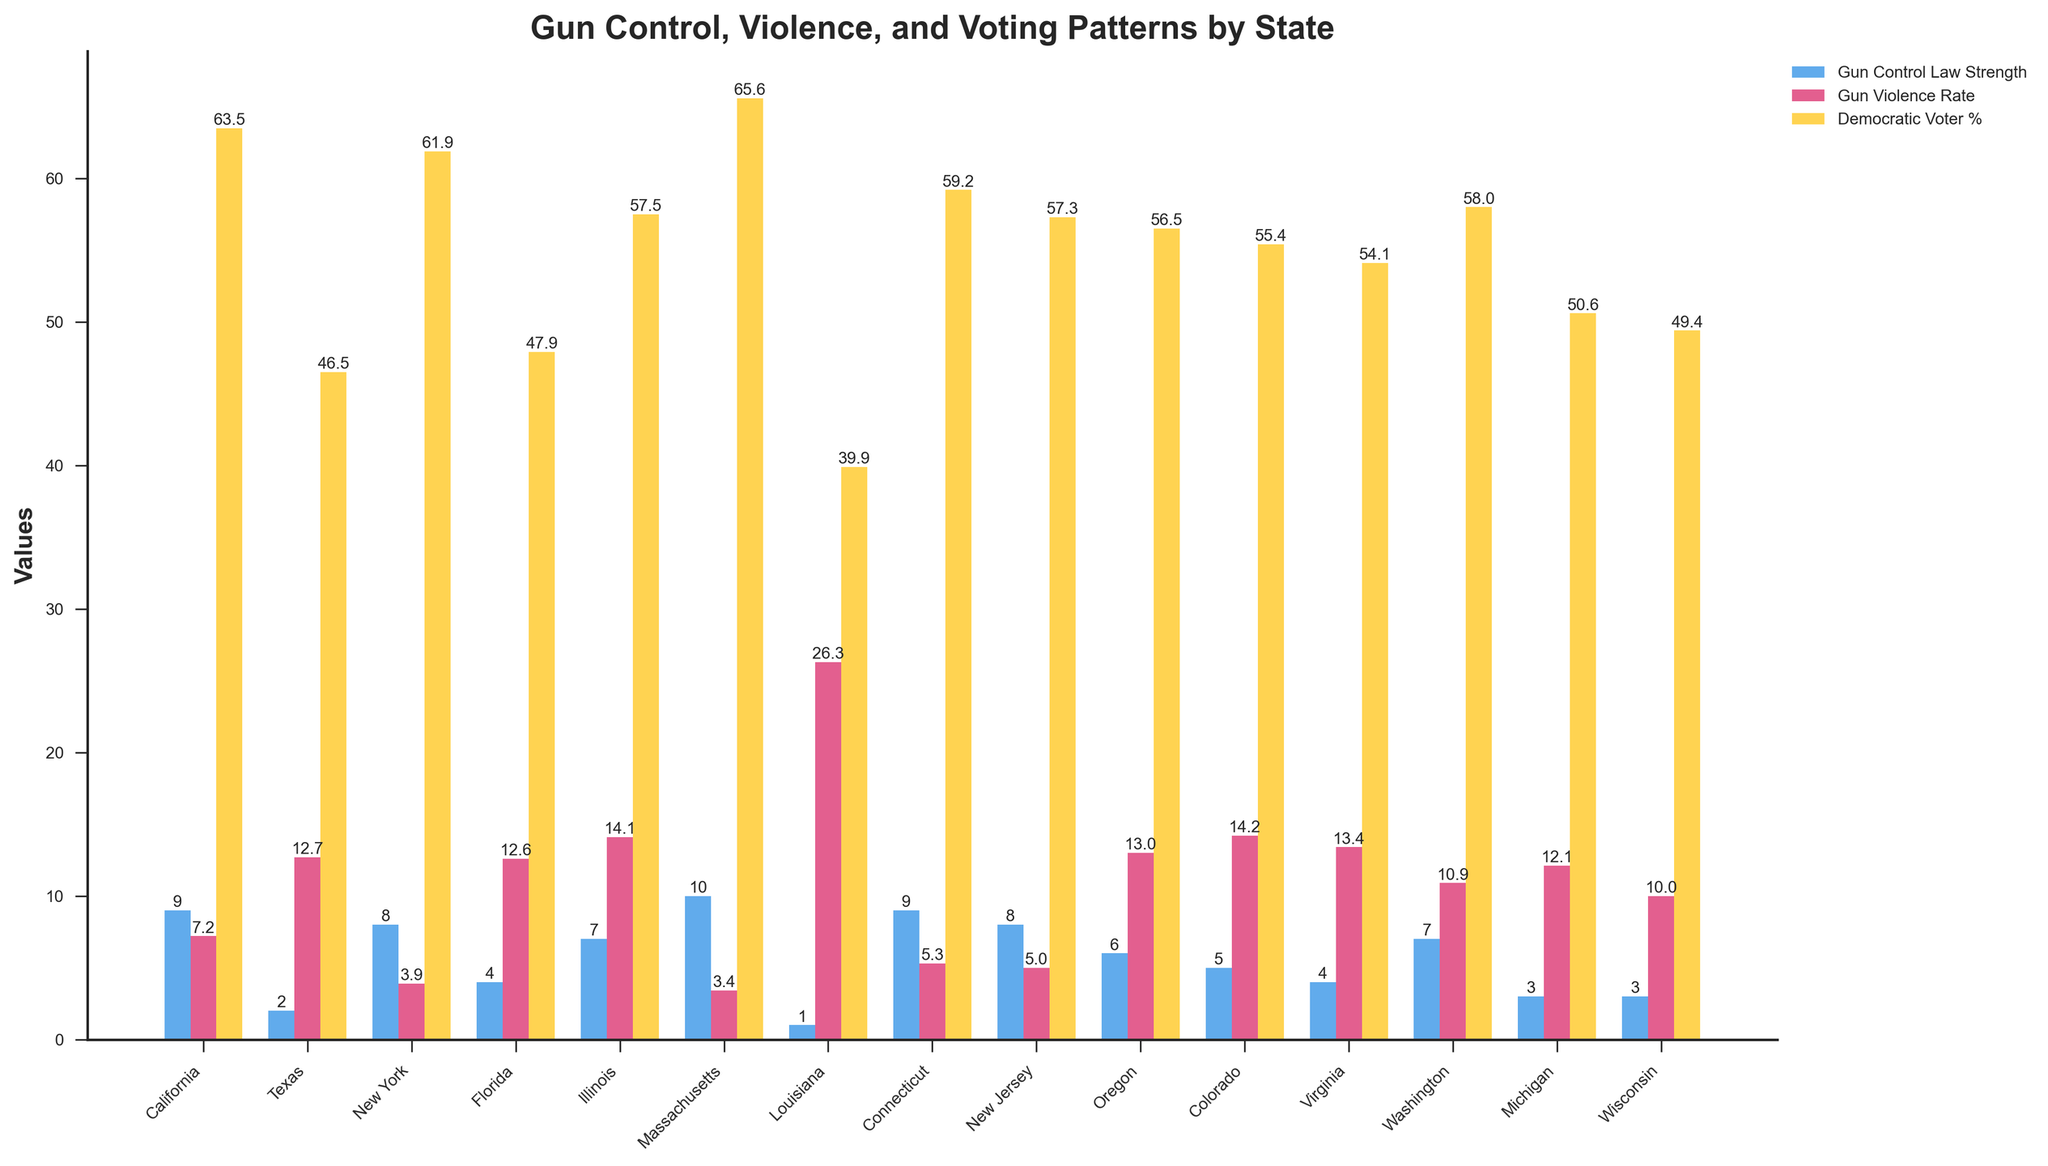What state has the highest gun violence rate and what is it? Identify the state with the tallest red bar and read the value on the bar.
Answer: Louisiana, 26.3 Which state has the strongest gun control laws and what is its gun violence rate? Locate the tallest blue bar, which represents gun control law strength, and then find the corresponding red bar representing the gun violence rate.
Answer: Massachusetts, 3.4 What is the difference in gun violence rates between California and Texas? Find the red bar values for California and Texas and subtract the smaller value from the larger one (12.7 - 7.2).
Answer: 5.5 Which state has a higher percentage of Democratic voters, New York or New Jersey? Compare the height of the yellow bars for New York and New Jersey.
Answer: New York, 61.9 How do the gun control law strengths of Florida and Virginia compare? Compare the heights of the blue bars for Florida and Virginia.
Answer: Equal, both 4 What is the average gun violence rate of states with a gun control law strength of 9? Identify states with blue bars of height 9 (California and Connecticut), then average their red bar values (7.2 + 5.3)/2.
Answer: 6.25 What state has the lowest gun violence rate and what is its gun control law strength? Identify the state with the shortest red bar and read the corresponding blue bar value.
Answer: Massachusetts, 10 Based on the figure, does a higher gun control law strength generally correlate with a lower gun violence rate? Observe the pattern between the blue and red bars across the states, noting inversely proportional trends.
Answer: Yes Which state with a gun control law strength of 6 also has the highest Democratic voter percentage? Identify the states with blue bars of height 6 (Oregon), then check the yellow bar value.
Answer: Oregon, 56.5 Among the states represented, which has the lowest percentage of Democratic voters and what is its gun violence rate? Find the shortest yellow bar, corresponding to Louisiana, and read its red bar value.
Answer: Louisiana, 26.3 